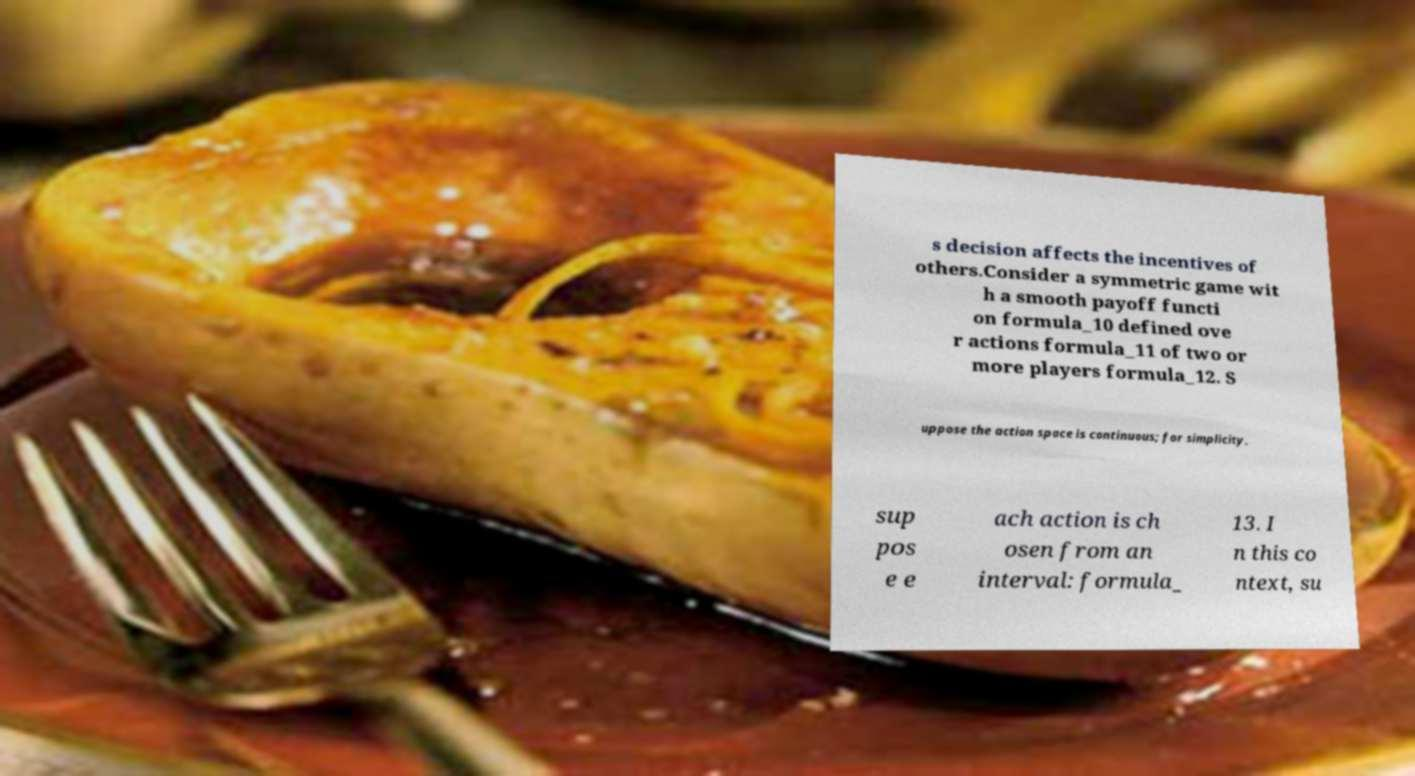Please identify and transcribe the text found in this image. s decision affects the incentives of others.Consider a symmetric game wit h a smooth payoff functi on formula_10 defined ove r actions formula_11 of two or more players formula_12. S uppose the action space is continuous; for simplicity, sup pos e e ach action is ch osen from an interval: formula_ 13. I n this co ntext, su 